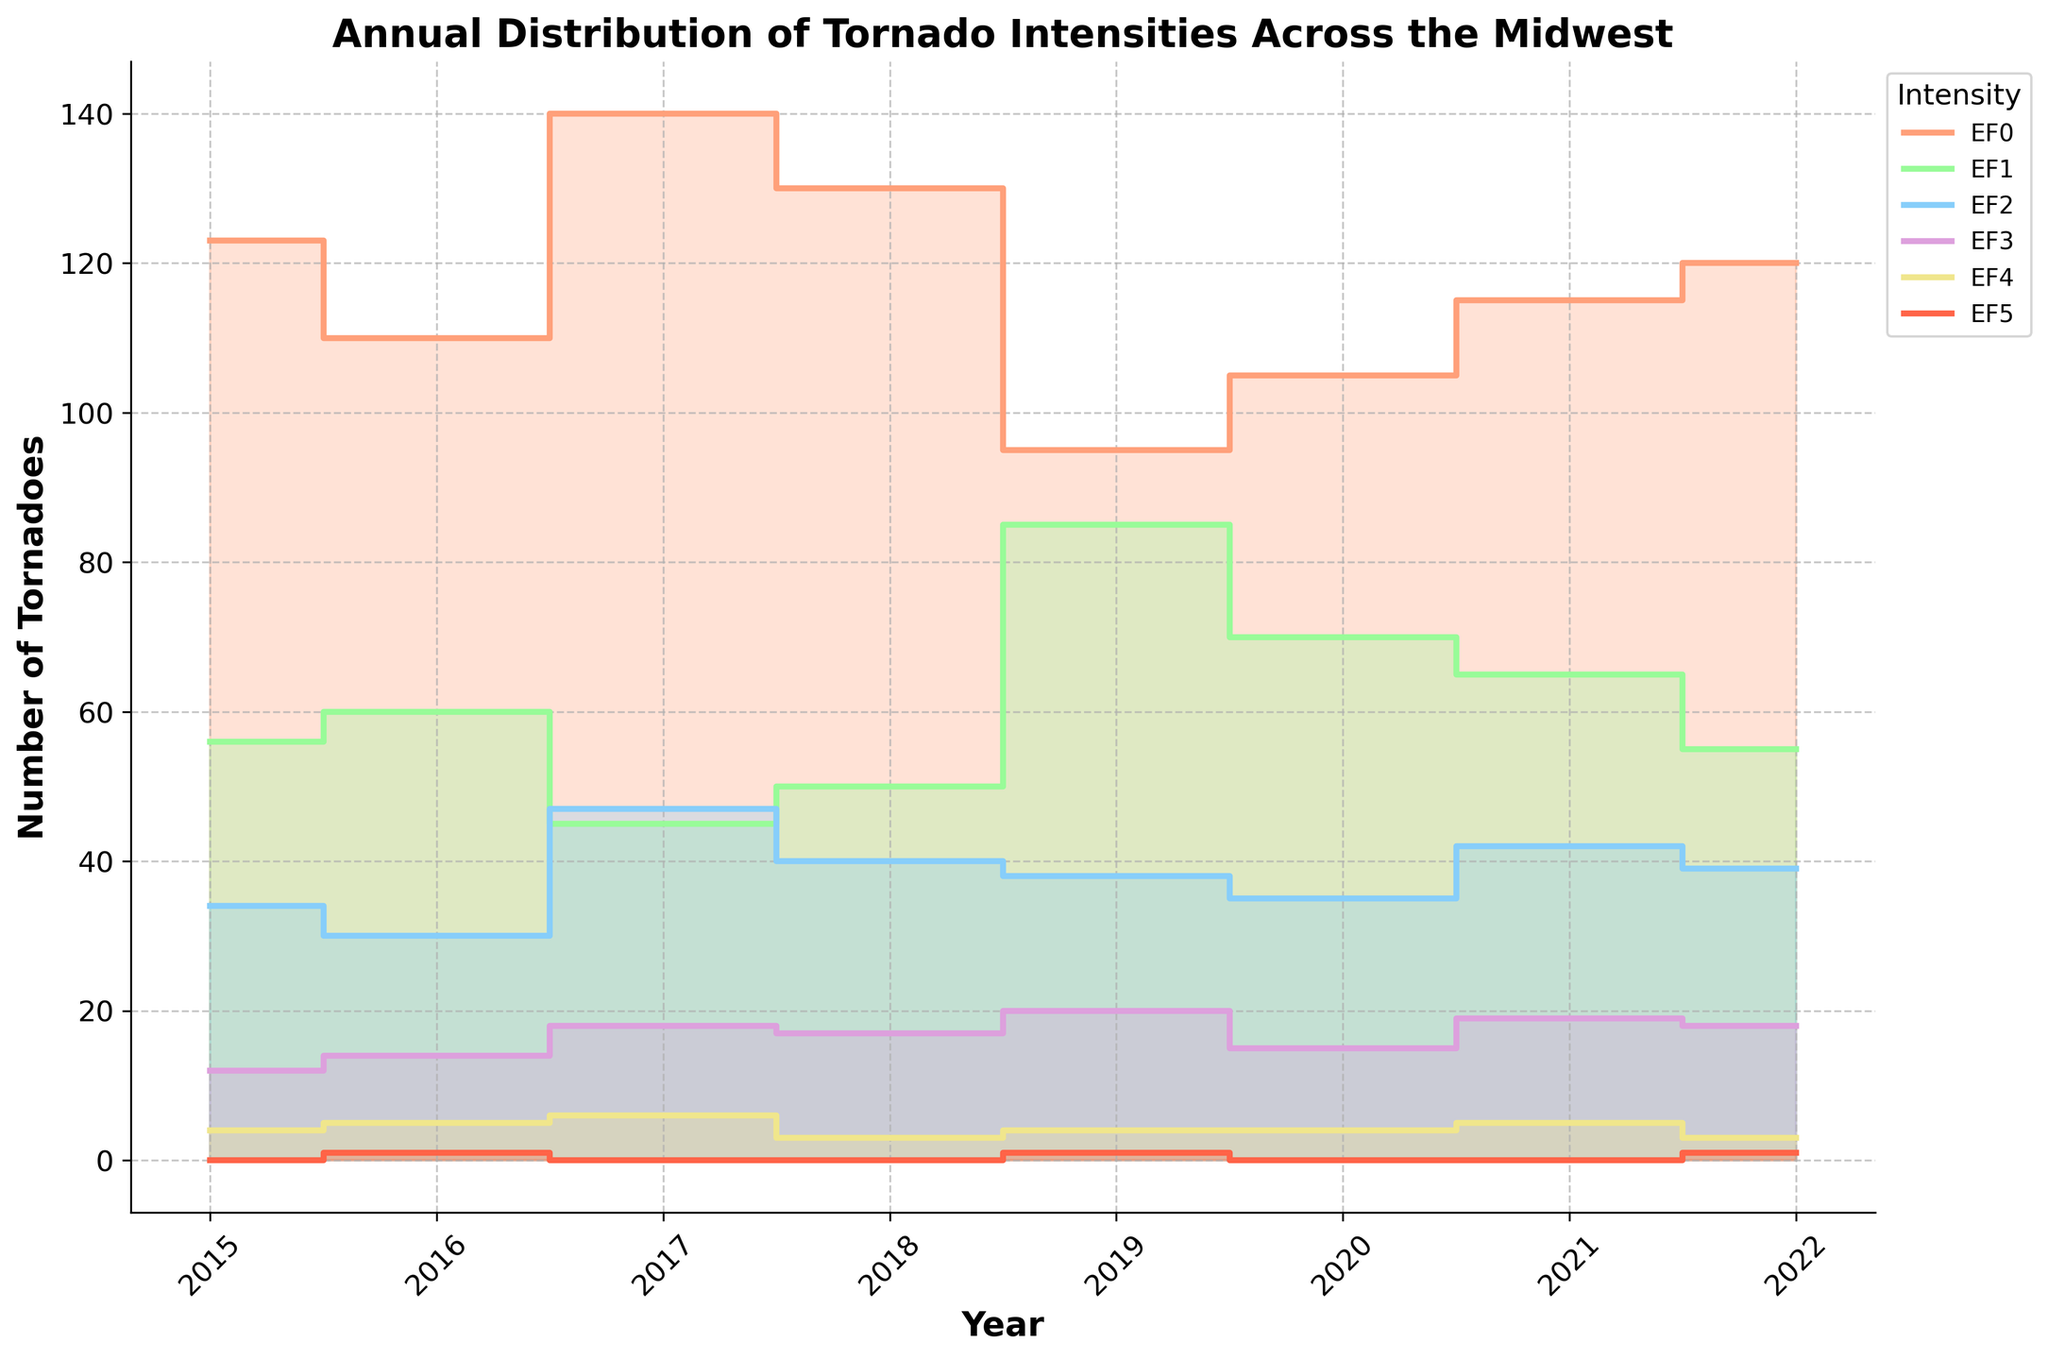Which year had the highest number of EF5 tornadoes? Look at the EF5 line and identify the year with the highest data point. The peak is seen in 2016 and 2019 with a value of 1.
Answer: 2016 and 2019 What's the total number of EF0 tornadoes from 2015 to 2022? Sum the EF0 values from 2015 to 2022: 123 + 110 + 140 + 130 + 95 + 105 + 115 + 120 = 938
Answer: 938 Which EF level had the most tornadoes in 2017? Check the 2017 data for each EF level and compare the values. EF0 has 140, EF1 has 45, EF2 has 47, EF3 has 18, EF4 has 6, and EF5 has 0. The highest is EF0.
Answer: EF0 How many more EF2 tornadoes were there in 2019 compared to 2016? Subtract EF2 tornadoes in 2016 from those in 2019: 38 - 30 = 8
Answer: 8 What's the average number of EF4 tornadoes per year from 2015 to 2022? Sum EF4 values for all years and divide by 8: (4 + 5 + 6 + 3 + 4 + 4 + 5 + 3) / 8 = 34 / 8 = 4.25
Answer: 4.25 In which year was the number of EF1 tornadoes closest to 60? Compare each year's EF1 value to 60 and find the closest one: 2016 has exactly 60.
Answer: 2016 Which year saw the highest number of total tornadoes across all EF levels? Sum the tornadoes in all EF levels for each year and compare. The highest sum is in 2017: 140 + 45 + 47 + 18 + 6 + 0 = 256.
Answer: 2017 How did the number of EF3 tornadoes change from 2015 to 2022? Look at the EF3 values from 2015 to 2022 and observe the trend. Starting at 12 in 2015, then fluctuating before ending at 18 in 2022.
Answer: Increased Which EF level shows the least variation in numbers from 2015 to 2022? Observe each EF level's line for the smallest fluctuations. EF4 and EF5 show the least variation, but EF5 has very few data points. EF4 runs between 3 and 6.
Answer: EF4 